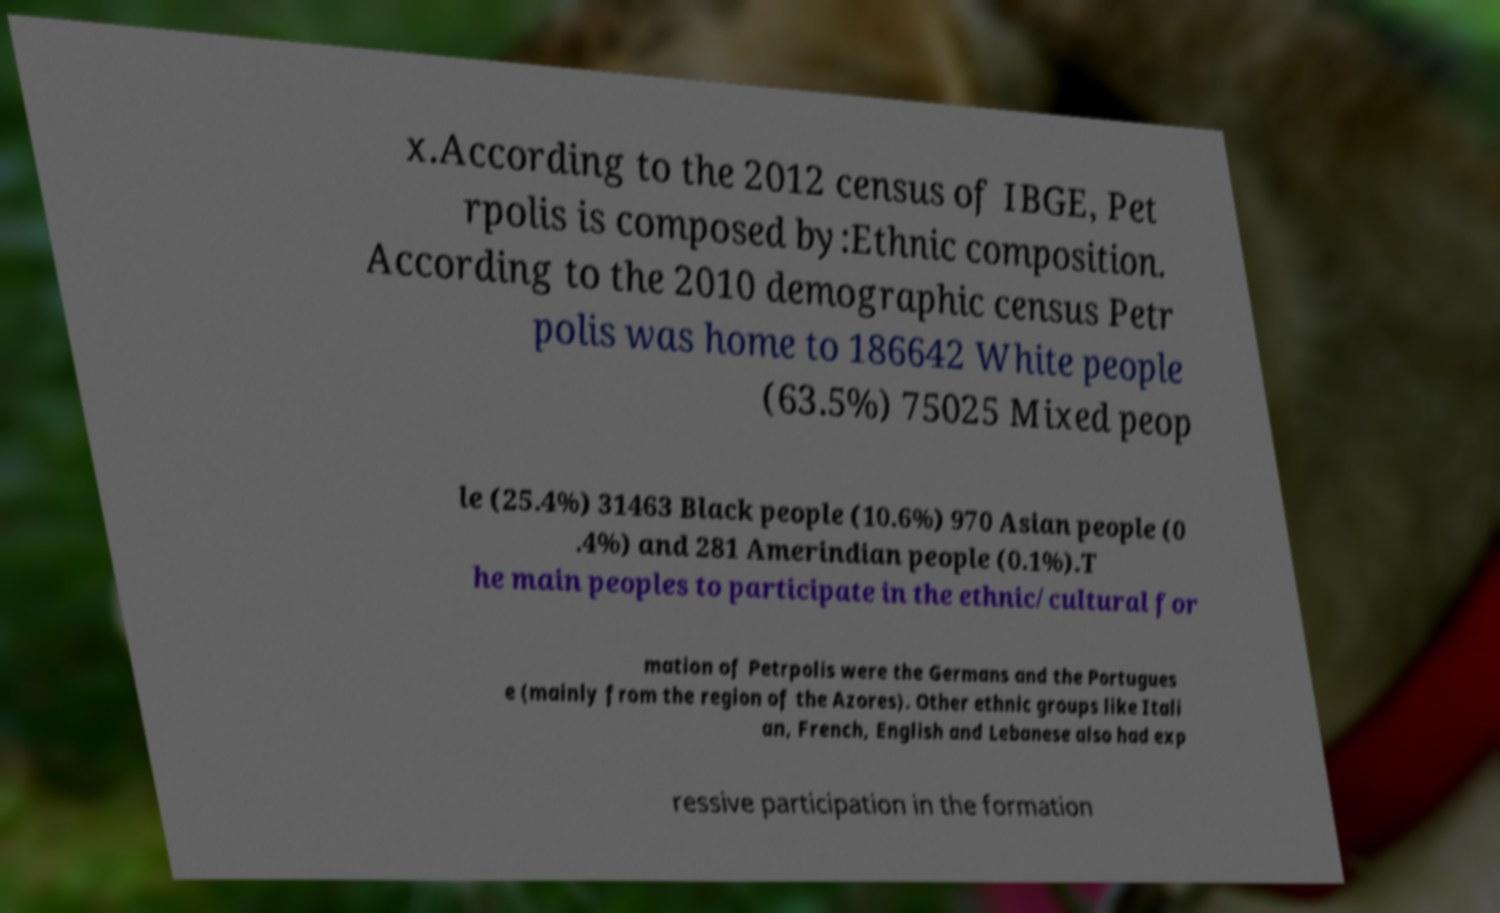There's text embedded in this image that I need extracted. Can you transcribe it verbatim? x.According to the 2012 census of IBGE, Pet rpolis is composed by:Ethnic composition. According to the 2010 demographic census Petr polis was home to 186642 White people (63.5%) 75025 Mixed peop le (25.4%) 31463 Black people (10.6%) 970 Asian people (0 .4%) and 281 Amerindian people (0.1%).T he main peoples to participate in the ethnic/cultural for mation of Petrpolis were the Germans and the Portugues e (mainly from the region of the Azores). Other ethnic groups like Itali an, French, English and Lebanese also had exp ressive participation in the formation 